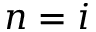<formula> <loc_0><loc_0><loc_500><loc_500>n = i</formula> 